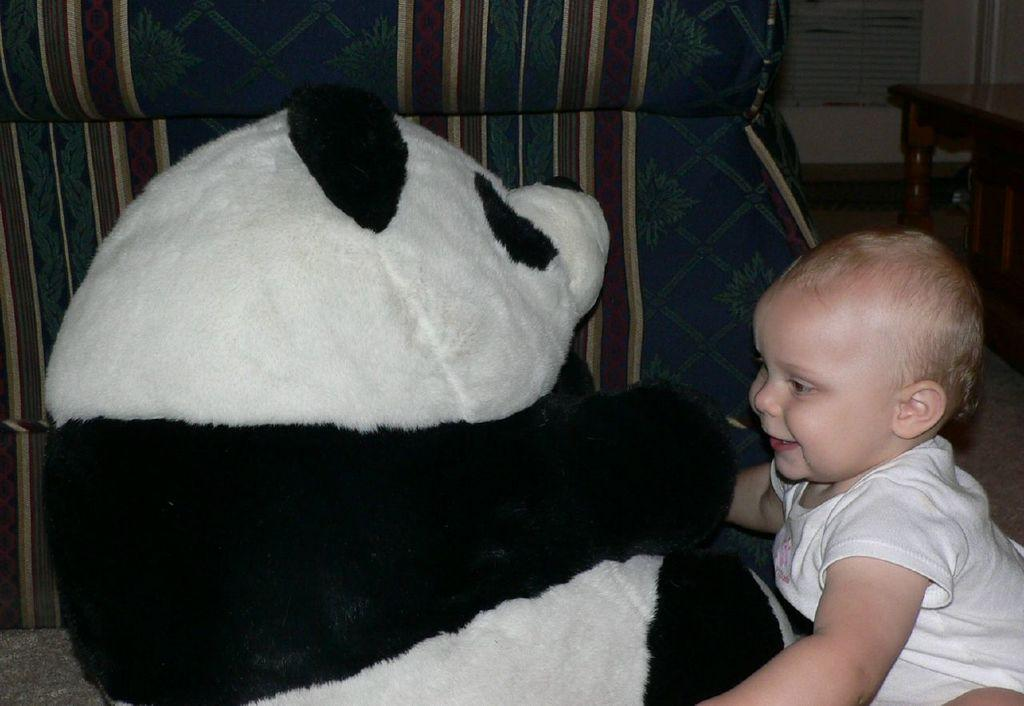What is located on the right side of the image? There is a baby on the right side of the image. What is the baby wearing? The baby is wearing a white dress. What expression does the baby have? The baby is smiling. What is the baby holding in the image? The baby is holding a doll. What colors are present on the doll? The doll has a white and black color combination. What can be seen in the background of the image? There is a table in the background of the image. What type of payment is being made in the image? There is no payment being made in the image; it features a baby holding a doll. How many books are visible in the image? There are no books visible in the image. 